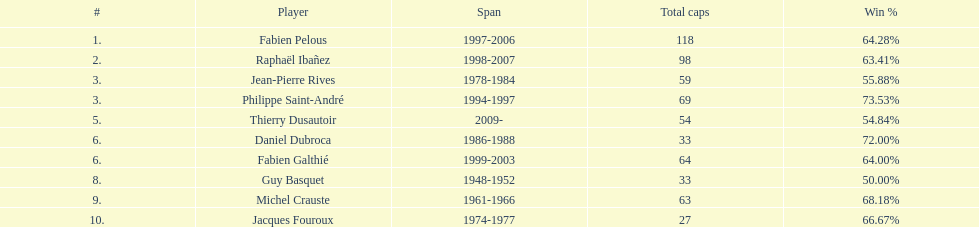What is the combined cap count for jean-pierre rives and michel crauste? 122. 